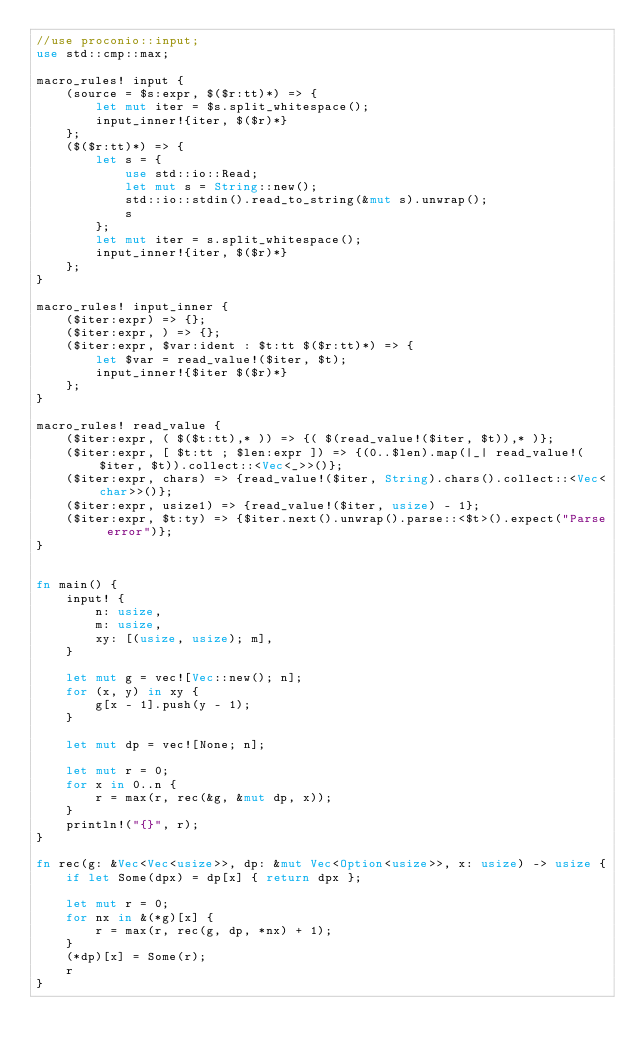<code> <loc_0><loc_0><loc_500><loc_500><_Rust_>//use proconio::input;
use std::cmp::max;

macro_rules! input {
    (source = $s:expr, $($r:tt)*) => {
        let mut iter = $s.split_whitespace();
        input_inner!{iter, $($r)*}
    };
    ($($r:tt)*) => {
        let s = {
            use std::io::Read;
            let mut s = String::new();
            std::io::stdin().read_to_string(&mut s).unwrap();
            s
        };
        let mut iter = s.split_whitespace();
        input_inner!{iter, $($r)*}
    };
}

macro_rules! input_inner {
    ($iter:expr) => {};
    ($iter:expr, ) => {};
    ($iter:expr, $var:ident : $t:tt $($r:tt)*) => {
        let $var = read_value!($iter, $t);
        input_inner!{$iter $($r)*}
    };
}

macro_rules! read_value {
    ($iter:expr, ( $($t:tt),* )) => {( $(read_value!($iter, $t)),* )};
    ($iter:expr, [ $t:tt ; $len:expr ]) => {(0..$len).map(|_| read_value!($iter, $t)).collect::<Vec<_>>()};
    ($iter:expr, chars) => {read_value!($iter, String).chars().collect::<Vec<char>>()};
    ($iter:expr, usize1) => {read_value!($iter, usize) - 1};
    ($iter:expr, $t:ty) => {$iter.next().unwrap().parse::<$t>().expect("Parse error")};
}


fn main() {
    input! {
        n: usize,
        m: usize,
        xy: [(usize, usize); m],
    }

    let mut g = vec![Vec::new(); n];
    for (x, y) in xy {
        g[x - 1].push(y - 1);
    }

    let mut dp = vec![None; n];

    let mut r = 0;
    for x in 0..n {
        r = max(r, rec(&g, &mut dp, x));
    }
    println!("{}", r);
}

fn rec(g: &Vec<Vec<usize>>, dp: &mut Vec<Option<usize>>, x: usize) -> usize {
    if let Some(dpx) = dp[x] { return dpx };

    let mut r = 0;
    for nx in &(*g)[x] {
        r = max(r, rec(g, dp, *nx) + 1);
    }
    (*dp)[x] = Some(r);
    r
}</code> 